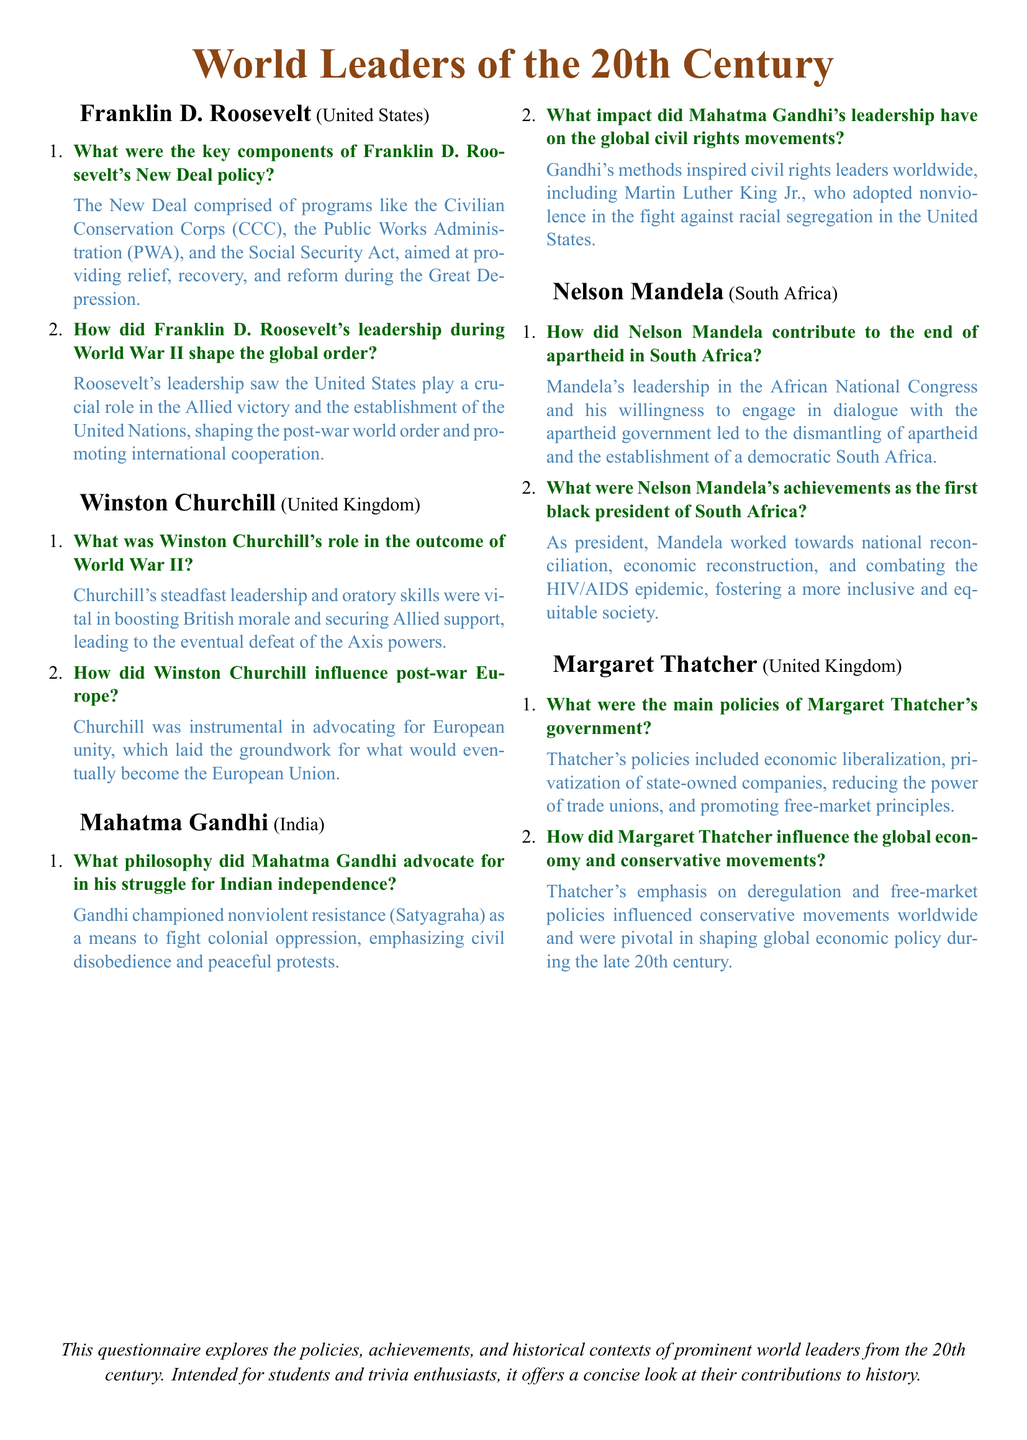What was the New Deal? The New Deal is described in the document as comprising programs aimed at providing relief, recovery, and reform during the Great Depression.
Answer: Relief, recovery, and reform Who led the African National Congress? The document states that Nelson Mandela's leadership in the African National Congress contributed to the end of apartheid in South Africa.
Answer: Nelson Mandela What philosophy did Mahatma Gandhi advocate? The document mentions that Gandhi advocated nonviolent resistance (Satyagraha) as a means to fight colonial oppression.
Answer: Nonviolent resistance (Satyagraha) What were the key policies of Margaret Thatcher's government? The answer states that Thatcher's policies included economic liberalization, privatization, and promoting free-market principles.
Answer: Economic liberalization, privatization, free-market principles How did Churchill influence post-war Europe? The document states that Churchill was instrumental in advocating for European unity, which laid the groundwork for the European Union.
Answer: Advocating for European unity What role did Franklin D. Roosevelt play in World War II? The document explains that Roosevelt's leadership saw the United States contribute significantly to the Allied victory and post-war global order.
Answer: Crucial role in Allied victory What impact did Gandhi's leadership have on global civil rights movements? The document notes that Gandhi's methods inspired civil rights leaders like Martin Luther King Jr.
Answer: Inspired civil rights leaders How did Nelson Mandela address the HIV/AIDS epidemic? According to the document, Mandela worked towards combating the HIV/AIDS epidemic as part of his achievements as president.
Answer: Combating the HIV/AIDS epidemic 